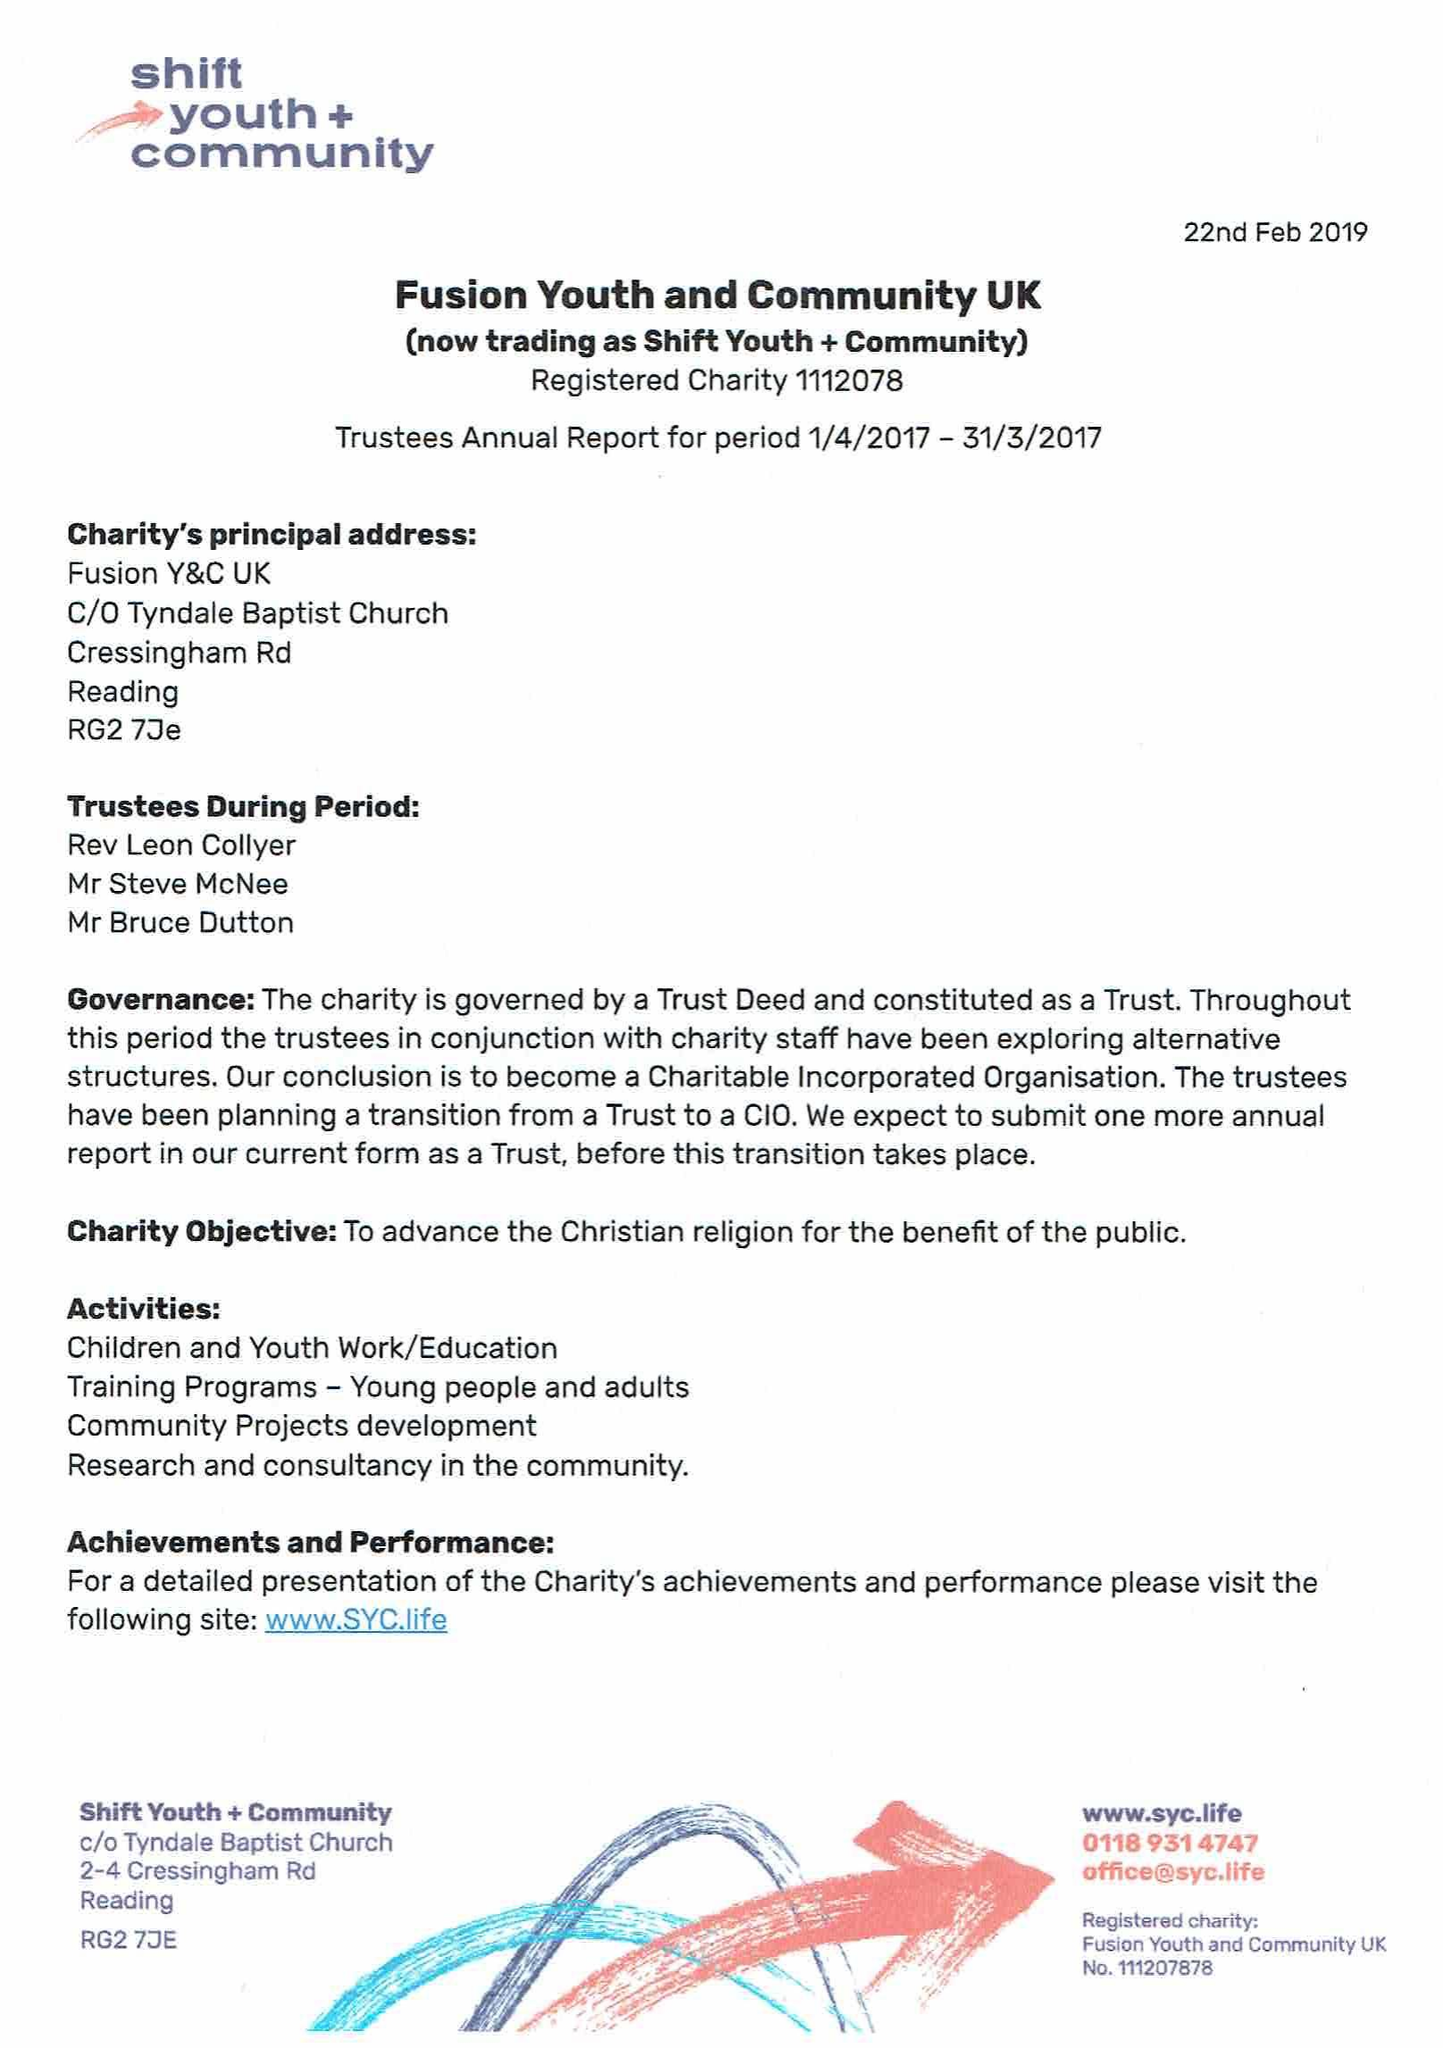What is the value for the income_annually_in_british_pounds?
Answer the question using a single word or phrase. 62317.00 